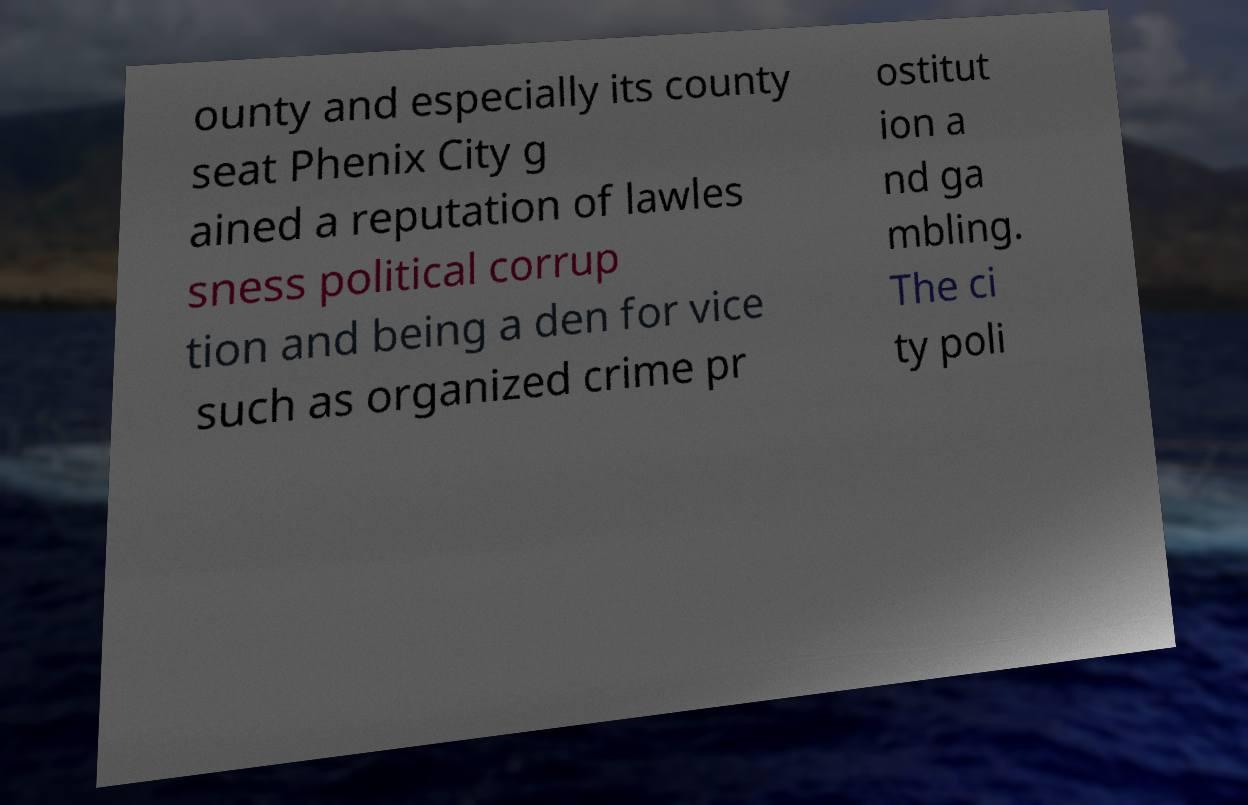Can you read and provide the text displayed in the image?This photo seems to have some interesting text. Can you extract and type it out for me? ounty and especially its county seat Phenix City g ained a reputation of lawles sness political corrup tion and being a den for vice such as organized crime pr ostitut ion a nd ga mbling. The ci ty poli 